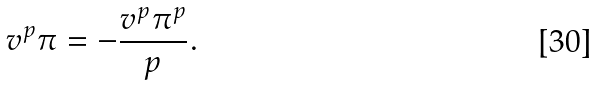Convert formula to latex. <formula><loc_0><loc_0><loc_500><loc_500>v ^ { p } \pi = - \frac { v ^ { p } \pi ^ { p } } { p } .</formula> 